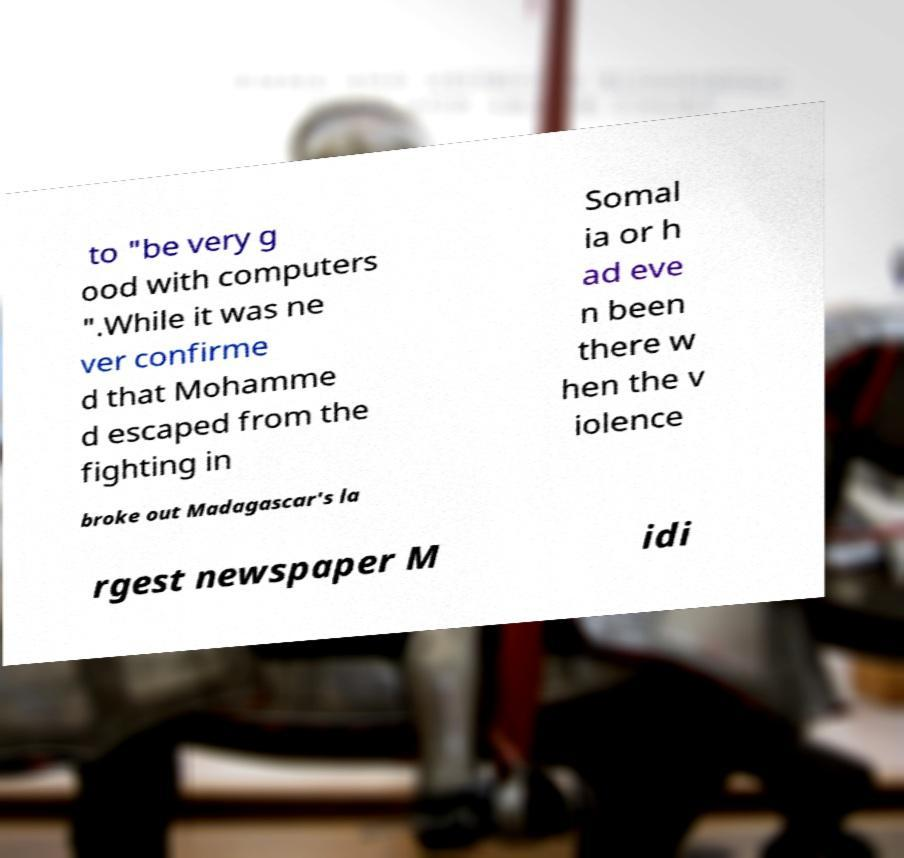Could you assist in decoding the text presented in this image and type it out clearly? to "be very g ood with computers ".While it was ne ver confirme d that Mohamme d escaped from the fighting in Somal ia or h ad eve n been there w hen the v iolence broke out Madagascar's la rgest newspaper M idi 